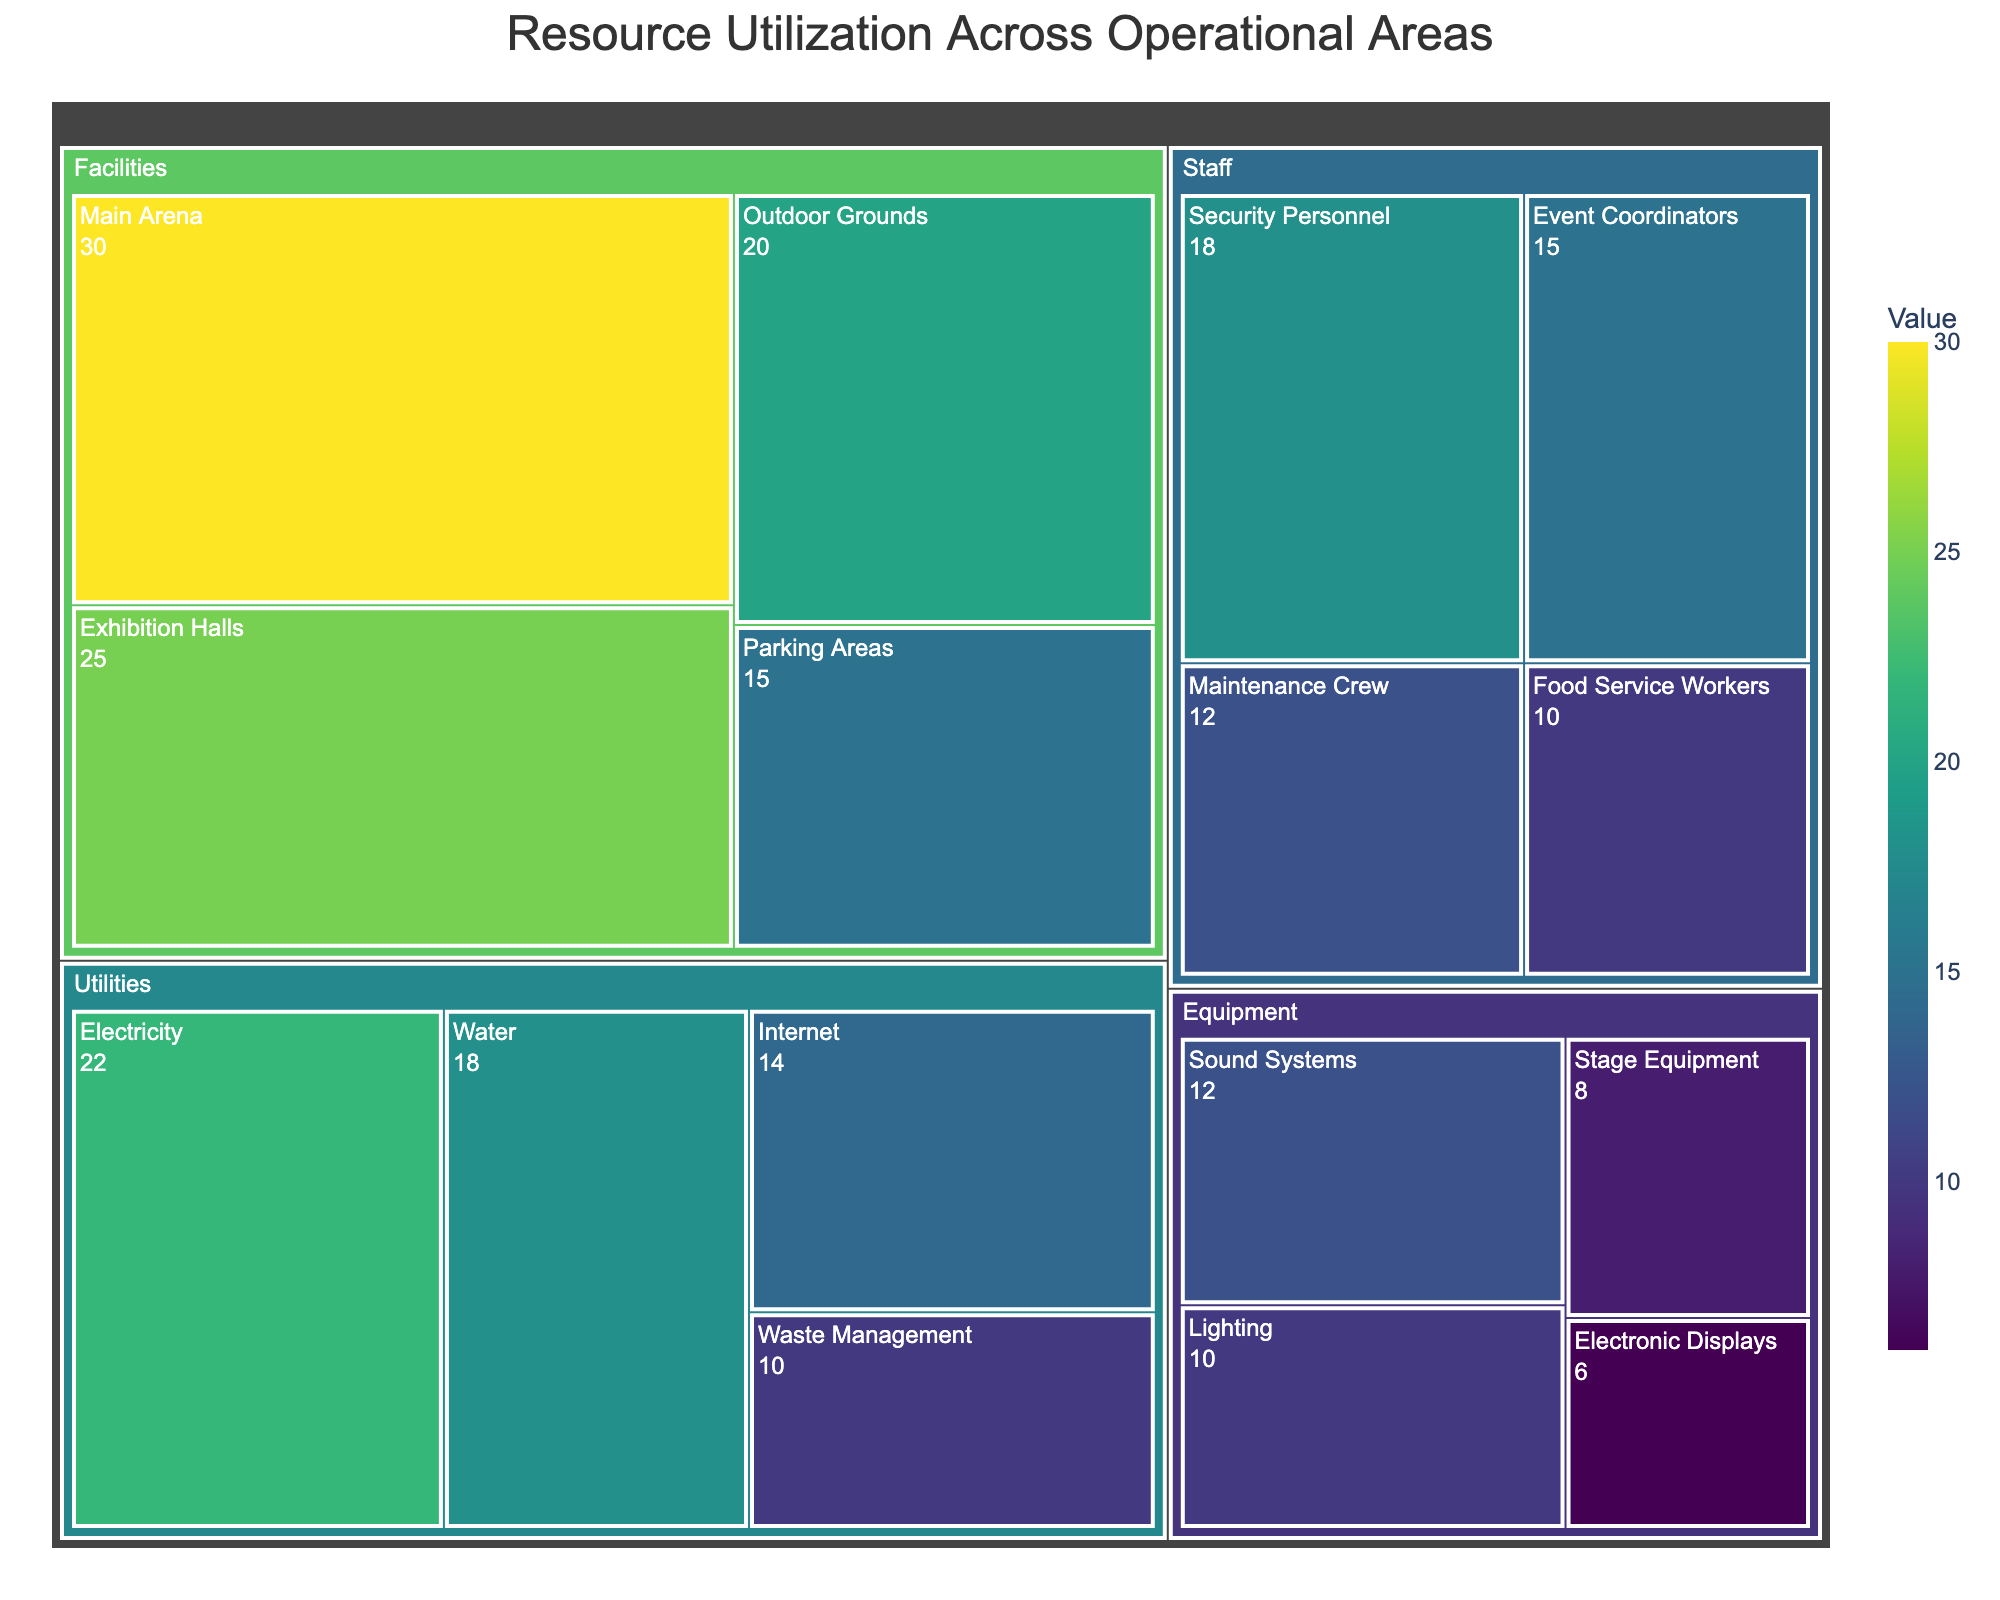What is the title of the treemap? The title is displayed at the top of the figure and gives an overview of what the treemap represents.
Answer: Resource Utilization Across Operational Areas Which subcategory has the highest value? The subcategory with the highest value can be identified by finding the largest rectangle in the treemap.
Answer: Main Arena What is the total value of the 'Utilities' category? Add up the values of the subcategories under 'Utilities': Electricity (22), Water (18), Internet (14), and Waste Management (10).
Answer: 64 Which category has the most subcategories? Count the number of subcategories within each main category to determine which has the most.
Answer: Staff Compare the values of 'Security Personnel' and 'Maintenance Crew' subcategories. Which one is greater and by how much? 'Security Personnel' has a value of 18, and 'Maintenance Crew' has a value of 12. Subtract the smaller value from the larger one to find the difference.
Answer: Security Personnel by 6 What is the combined value of 'Sound Systems' and 'Lighting'? Add the values of 'Sound Systems' (12) and 'Lighting' (10) to find the total.
Answer: 22 Which category has the second-highest total value? Calculate the total values for each category and identify the one with the second highest total. Facilities: 90, Equipment: 36, Staff: 55, Utilities: 64. The second highest is Utilities.
Answer: Utilities What is the value difference between the 'Main Arena' and the 'Parking Areas'? Subtract the value of 'Parking Areas' (15) from 'Main Arena' (30) to find the difference.
Answer: 15 What's the average value of all subcategories under 'Staff'? Add up all the values of 'Staff' subcategories and divide by the number of subcategories. (18 + 15 + 12 + 10) / 4 = 13.75
Answer: 13.75 Which subcategory is the smallest within the 'Equipment' category? Identify the smallest rectangle under the 'Equipment' category.
Answer: Electronic Displays 